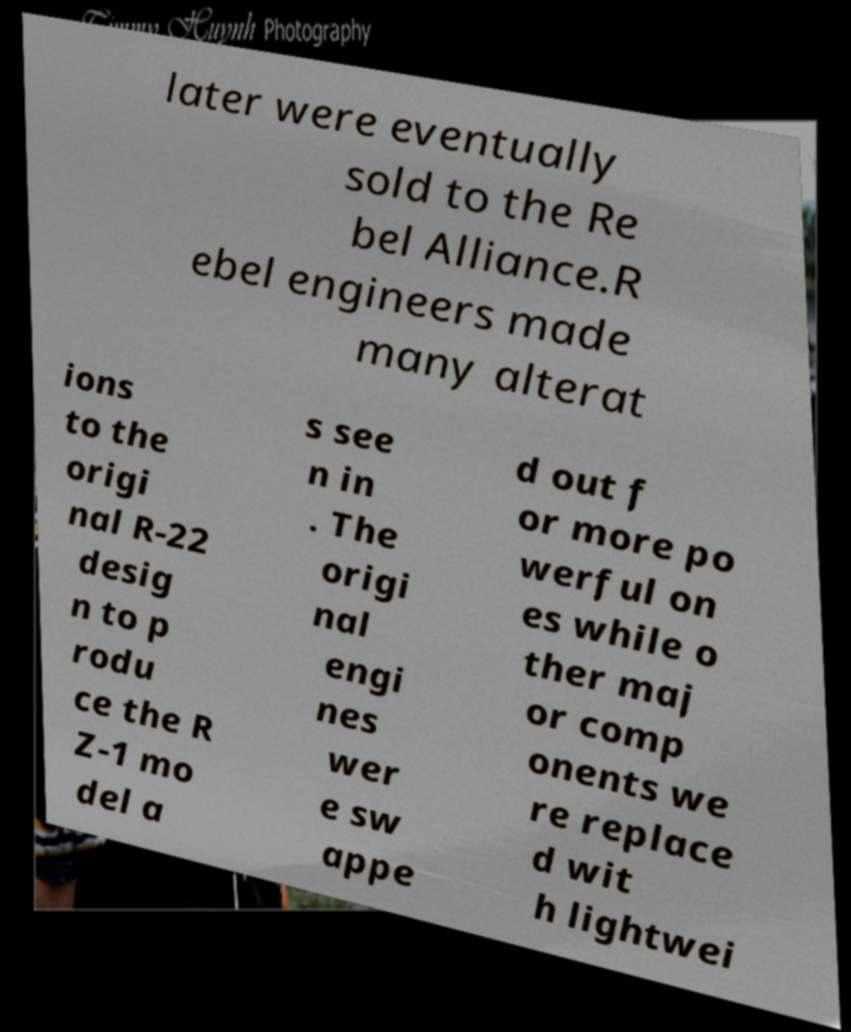Can you accurately transcribe the text from the provided image for me? later were eventually sold to the Re bel Alliance.R ebel engineers made many alterat ions to the origi nal R-22 desig n to p rodu ce the R Z-1 mo del a s see n in . The origi nal engi nes wer e sw appe d out f or more po werful on es while o ther maj or comp onents we re replace d wit h lightwei 